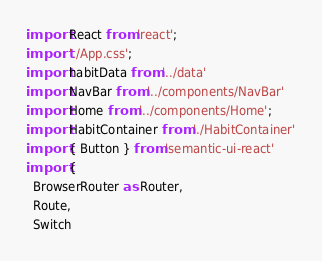<code> <loc_0><loc_0><loc_500><loc_500><_JavaScript_>import React from 'react';
import './App.css';
import habitData from '../data'
import NavBar from '../components/NavBar'
import Home from '../components/Home';
import HabitContainer from './HabitContainer'
import { Button } from 'semantic-ui-react'
import {
  BrowserRouter as Router,
  Route,
  Switch</code> 